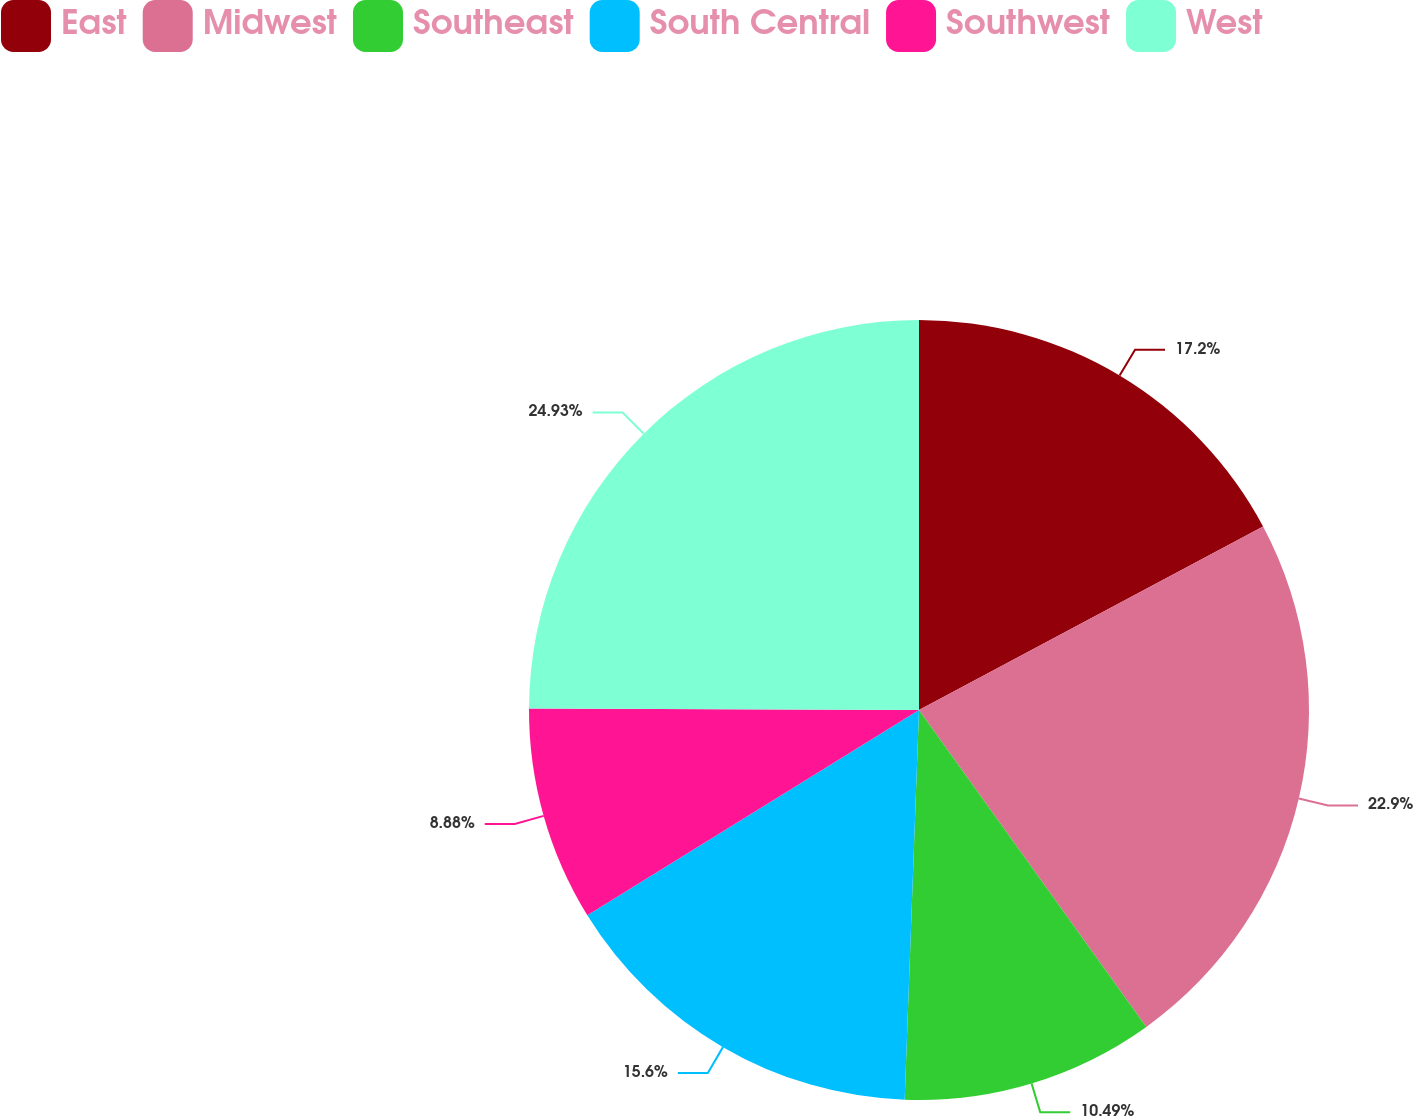Convert chart. <chart><loc_0><loc_0><loc_500><loc_500><pie_chart><fcel>East<fcel>Midwest<fcel>Southeast<fcel>South Central<fcel>Southwest<fcel>West<nl><fcel>17.2%<fcel>22.9%<fcel>10.49%<fcel>15.6%<fcel>8.88%<fcel>24.94%<nl></chart> 